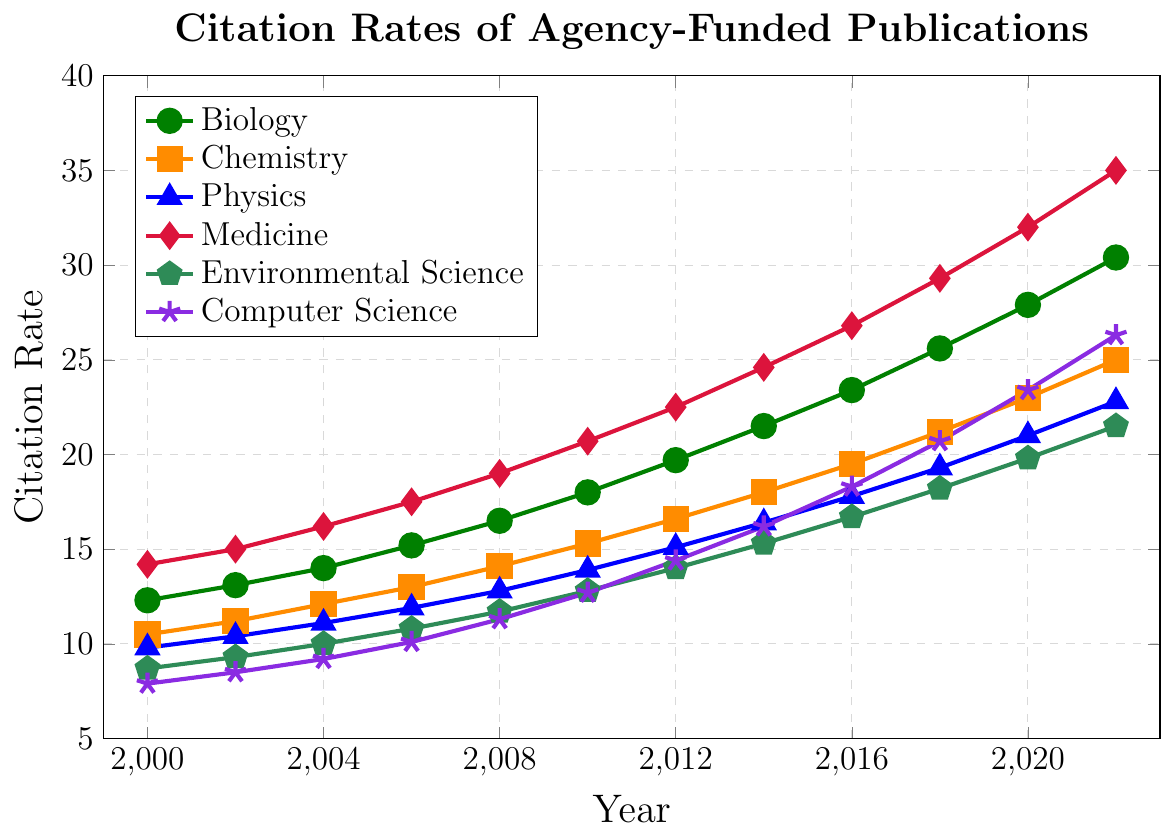Which discipline had the highest citation rate in 2022? To find the discipline with the highest citation rate, look at the endpoint (2022) of each line in the graph and compare the values. Medicine has the highest citation rate at 35.0.
Answer: Medicine What was the citation rate for Chemistry in 2010? Locate the year 2010 along the x-axis, then identify the point on the Chemistry line (colored orange) at that year. The citation rate for Chemistry in 2010 is 15.3.
Answer: 15.3 How much did the citation rate for Environmental Science increase from 2000 to 2022? Locate the citation rates for Environmental Science in 2000 and 2022 on the graph, then subtract the value of 2000 from the value of 2022. The citation rate increased from 8.7 in 2000 to 21.5 in 2022, an increase of 21.5 - 8.7 = 12.8.
Answer: 12.8 Between which consecutive years did Computer Science see the highest increase in citation rate? Examine the Computer Science line (colored purple) and identify the steepest upward slope. The steepest increase occurs between 2010 and 2012, where the citation rate increased from 12.7 to 14.4, which is an increase of 1.7.
Answer: 2010 to 2012 Which two disciplines had nearly equal citation rates in 2008? Locate the year 2008 on the x-axis and compare the points for each discipline to see which are closest in value. Biology (16.5) and Chemistry (14.1) have nearly equal citation rates in 2008. The rates are close but not equal.
Answer: Biology and Chemistry What is the percent increase in citation rate for Medicine from 2006 to 2016? Find the citation rates for Medicine in 2006 (17.5) and 2016 (26.8), then calculate the percent increase using the formula: ((26.8 - 17.5) / 17.5) * 100%. This gives ((26.8 - 17.5) / 17.5) * 100% ≈ 53.14%.
Answer: 53.14% What is the average citation rate of Physics over the entire period shown? Sum the citation rates for Physics over all the years and divide by the number of data points: (9.8 + 10.4 + 11.1 + 11.9 + 12.8 + 13.9 + 15.1 + 16.4 + 17.8 + 19.3 + 21.0 + 22.8) / 12. The sum is 182.3, so the average is 182.3 / 12 ≈ 15.19.
Answer: 15.19 In what year did Biology surpass a citation rate of 20? Follow the trend line for Biology (colored green) and identify the first year where the citation rate exceeds 20. The citation rate for Biology surpasses 20 in 2014.
Answer: 2014 How does the citation trend for Computer Science compare to Environmental Science between 2000 and 2022? Compare the slopes of the Computer Science and Environmental Science lines between 2000 and 2022. Both show an increasing trend, but Computer Science (from 7.9 to 26.3) has a steeper and more consistent rise than Environmental Science (from 8.7 to 21.5).
Answer: Computer Science has a steeper rise than Environmental Science 